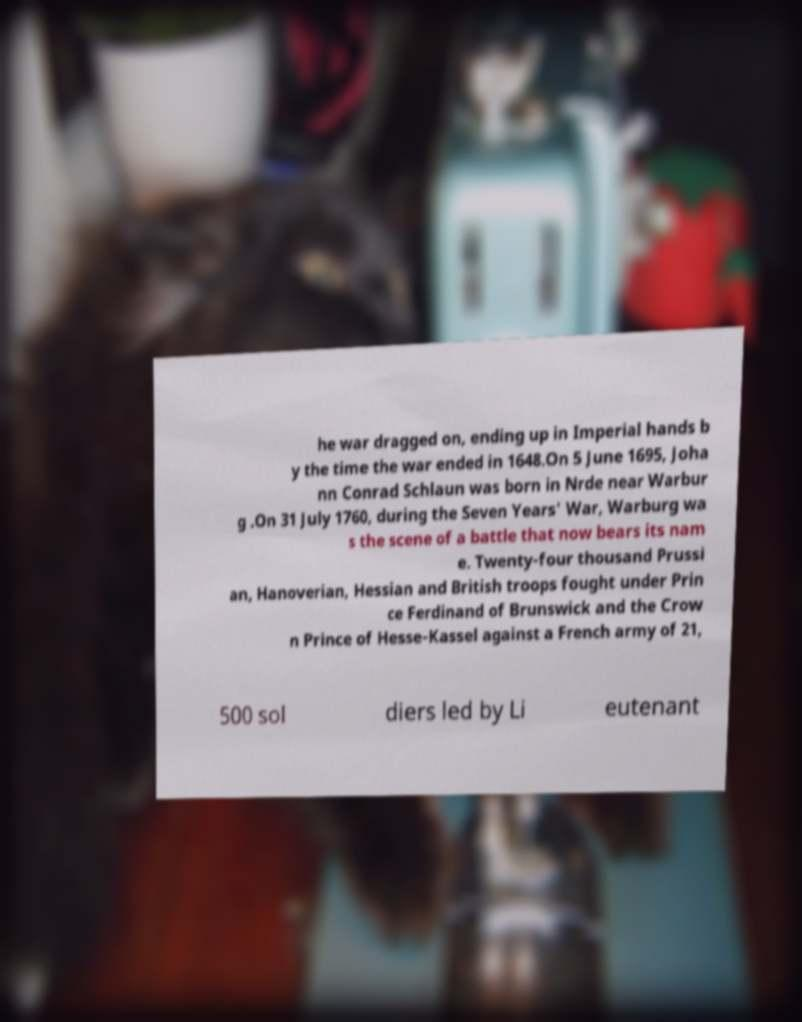Please identify and transcribe the text found in this image. he war dragged on, ending up in Imperial hands b y the time the war ended in 1648.On 5 June 1695, Joha nn Conrad Schlaun was born in Nrde near Warbur g .On 31 July 1760, during the Seven Years' War, Warburg wa s the scene of a battle that now bears its nam e. Twenty-four thousand Prussi an, Hanoverian, Hessian and British troops fought under Prin ce Ferdinand of Brunswick and the Crow n Prince of Hesse-Kassel against a French army of 21, 500 sol diers led by Li eutenant 